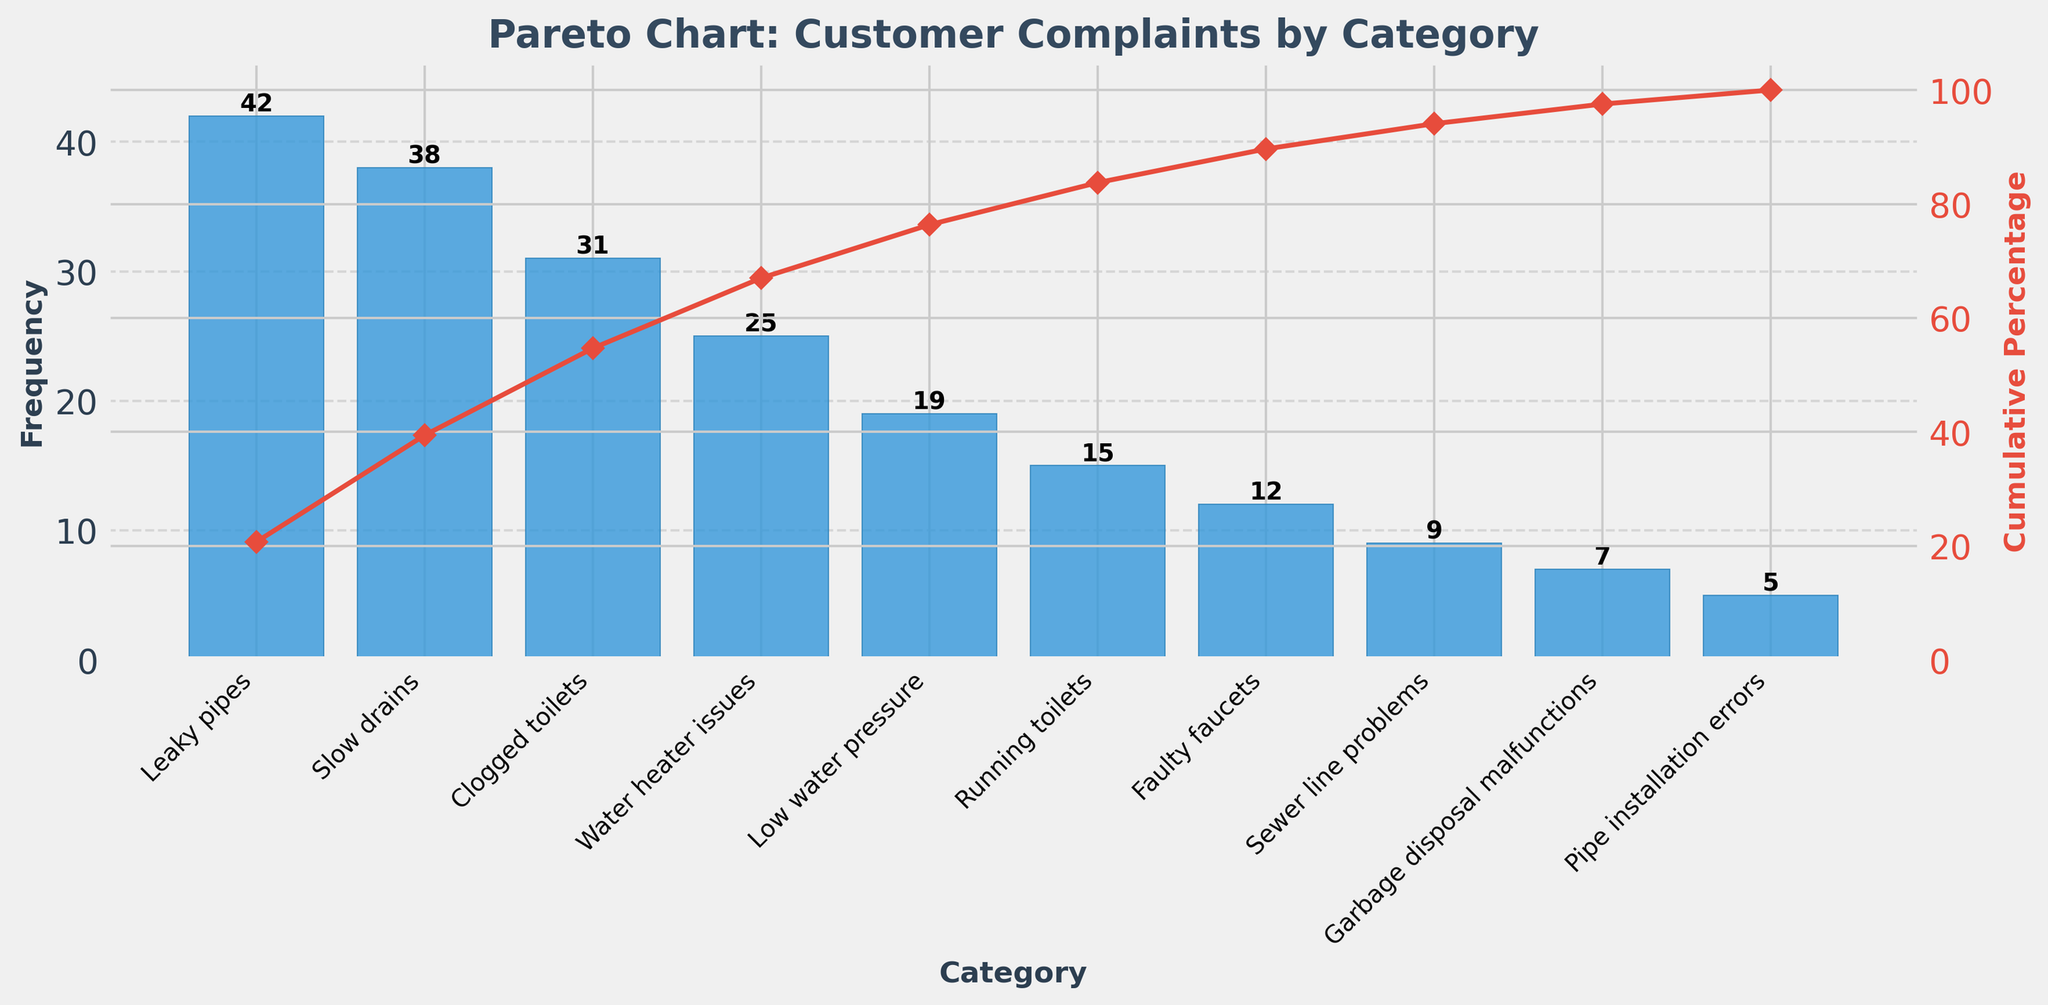What is the most frequent customer complaint category? The most frequent category is at the far left of the Pareto chart. It is "Leaky pipes" with a frequency of 42.
Answer: Leaky pipes Which category has the fewest complaints? The category with the fewest complaints is at the far right of the Pareto chart. It is "Pipe installation errors" with a frequency of 5.
Answer: Pipe installation errors What is the cumulative percentage after the first three categories? Sum the complaints of the first three categories: 42 (Leaky pipes) + 38 (Slow drains) + 31 (Clogged toilets) = 111. The total number of complaints is 203. The cumulative percentage is (111 / 203) * 100 ≈ 54.68%.
Answer: About 54.68% How many categories account for over 80% of the complaints? Check the cumulative percentage line until it exceeds 80%. This occurs after "Clogged toilets" (15.27%) + "Slow drains" (25.60%) + "Leaky pipes" (20.69%) + "Water heater issues" (12.32%) + "Low water pressure" (9.36%) ≈ 83.24%. Thus, five categories account for over 80%.
Answer: 5 What is the total number of complaints? Sum all the frequencies: 42 + 38 + 31 + 25 + 19 + 15 + 12 + 9 + 7 + 5 = 203.
Answer: 203 What percentage do "Garbage disposal malfunctions" and "Pipe installation errors" contribute together? Sum the frequencies: 7 (Garbage disposal malfunctions) + 5 (Pipe installation errors) = 12. Calculate the percentage: (12 / 203) * 100 ≈ 5.91%.
Answer: About 5.91% Which category is more frequent: "Faulty faucets" or "Running toilets"? Compare the frequencies: "Running toilets" has 15 and "Faulty faucets" has 12. Therefore, "Running toilets" is more frequent.
Answer: Running toilets What is the frequency difference between "Leaky pipes" and "Slow drains"? Subtract the frequency of "Slow drains" from "Leaky pipes": 42 - 38 = 4.
Answer: 4 How many complaints fall into the top four categories? Sum the frequencies of the top four categories: 42 (Leaky pipes) + 38 (Slow drains) + 31 (Clogged toilets) + 25 (Water heater issues) = 136.
Answer: 136 From the bar colors, can you tell if the categories' bars and the cumulative percentage line share any visual relation? The bars are blue and the cumulative percentage line is red; the different colors help to visually distinguish between the categories' frequencies and the cumulative percentage.
Answer: No 